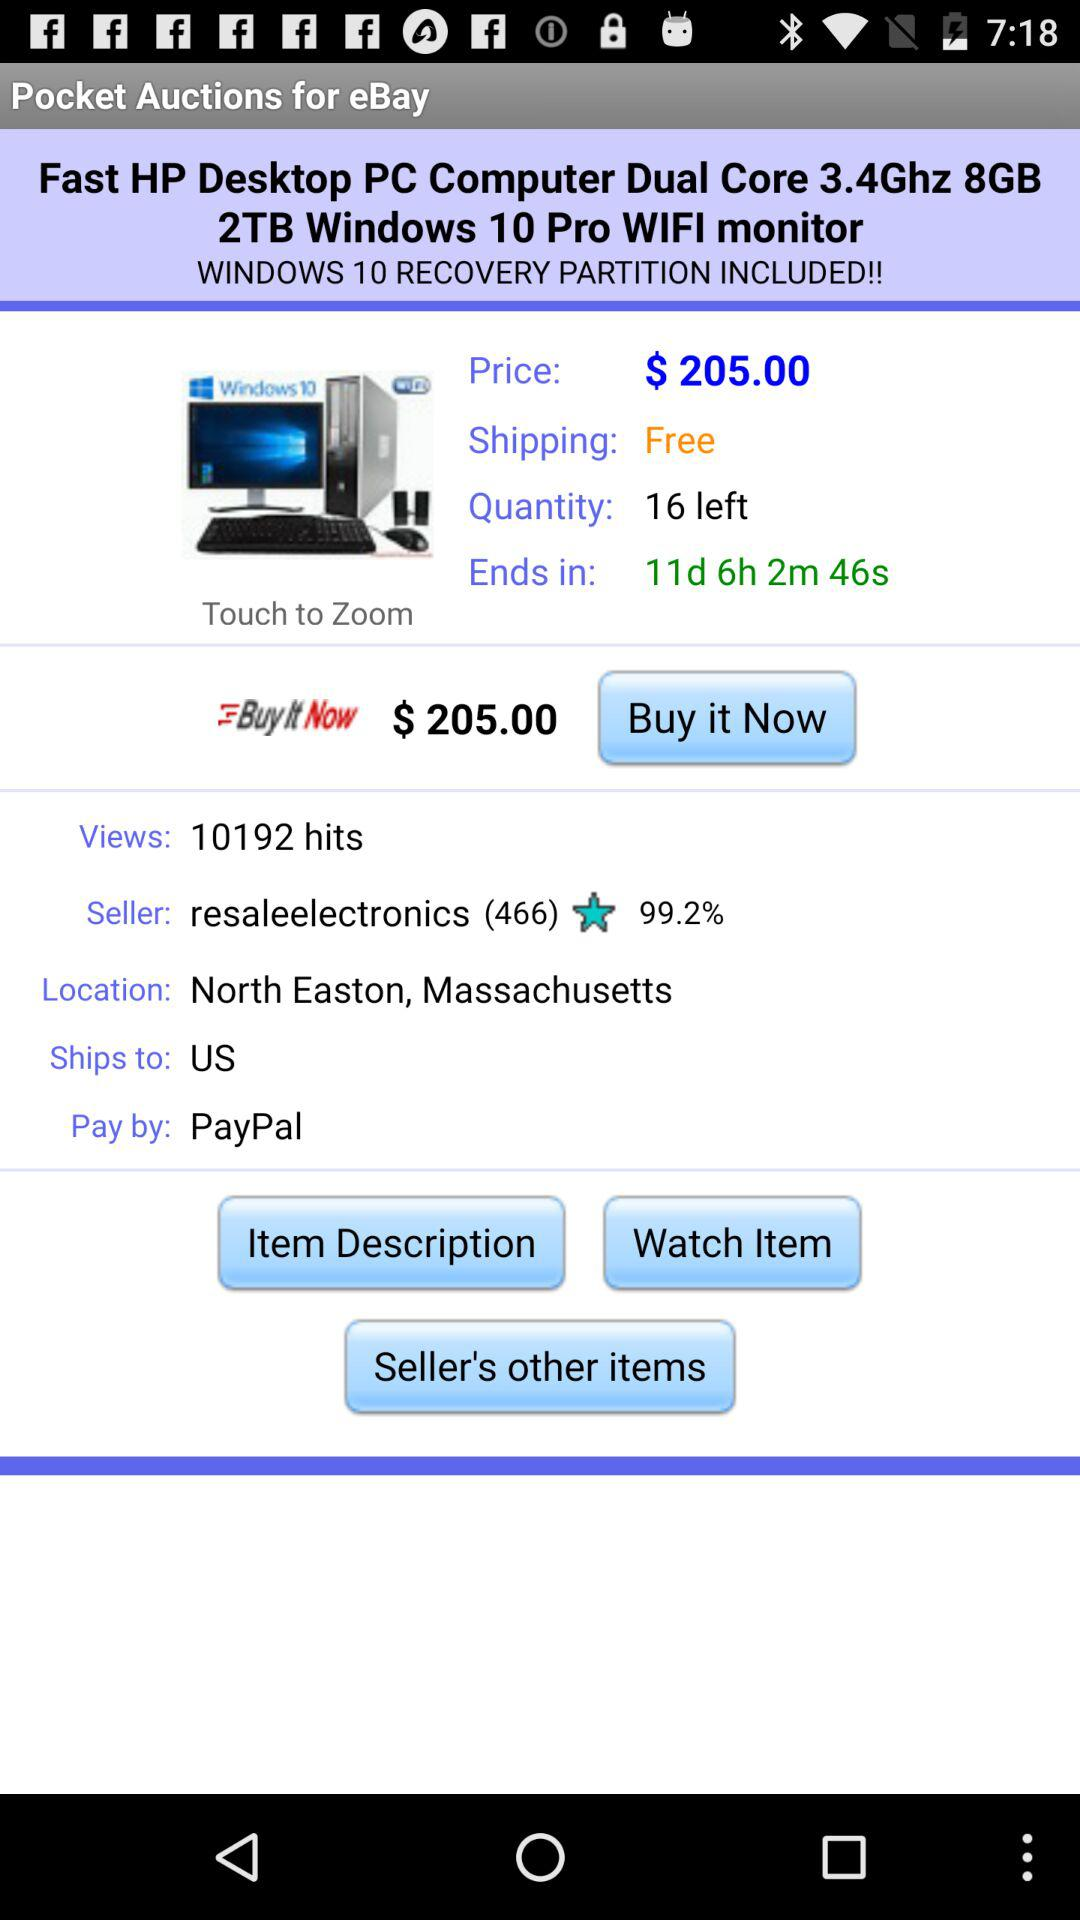How many views are there? The number of views is 10192. 